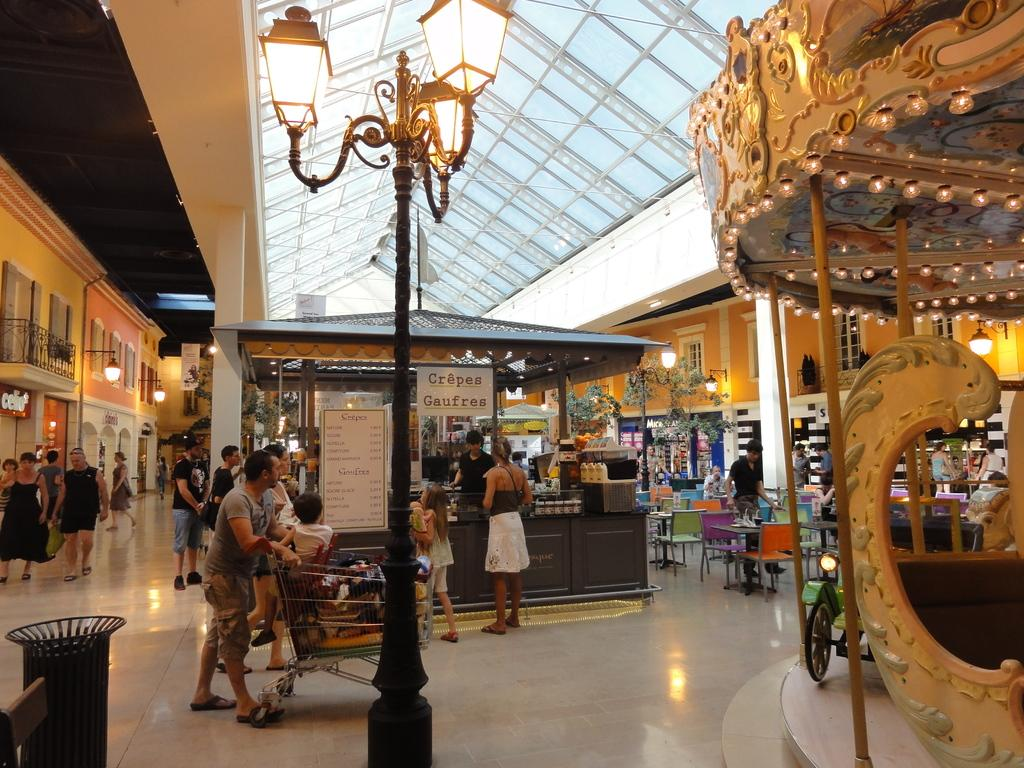What can be seen in the image? There are people, lights on a pole, a board, chairs, a stall, and windows in the background. Can you describe the lighting in the image? There are lights on a pole and lights visible in the background. What type of structure is present in the image? There is a stall in the image. What is the background of the image like? The background of the image includes windows and a wall. Can you tell me how many pieces of furniture are visible in the image? There is no furniture present in the image; it features people, lights, a board, chairs, a stall, windows, and a wall. Are there any parents visible in the image? There is no mention of parents in the image, only people in general. 